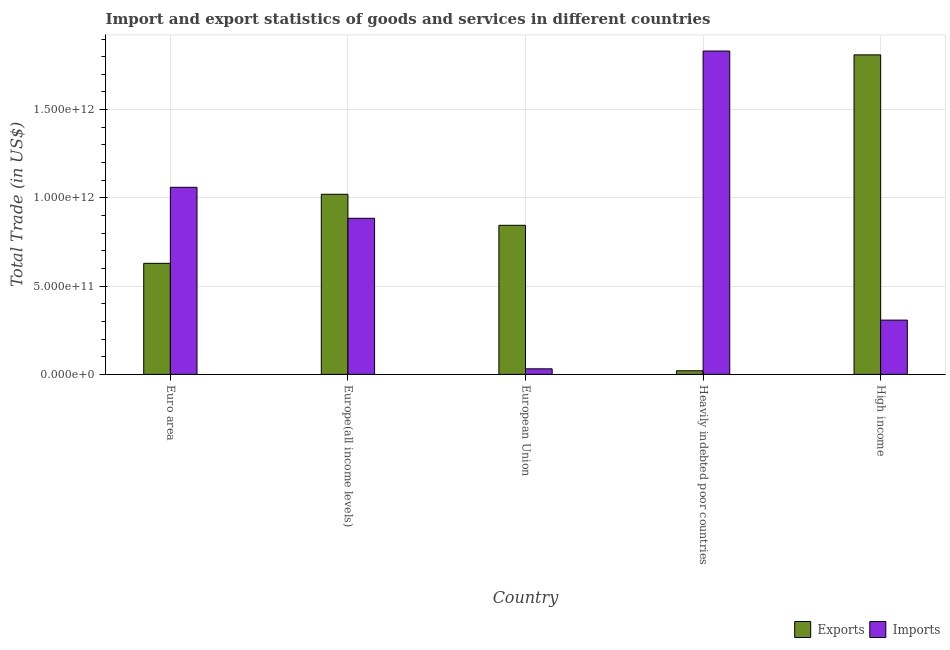How many different coloured bars are there?
Provide a short and direct response. 2. Are the number of bars per tick equal to the number of legend labels?
Offer a terse response. Yes. Are the number of bars on each tick of the X-axis equal?
Keep it short and to the point. Yes. How many bars are there on the 1st tick from the left?
Offer a very short reply. 2. How many bars are there on the 1st tick from the right?
Offer a very short reply. 2. What is the imports of goods and services in European Union?
Make the answer very short. 3.15e+1. Across all countries, what is the maximum imports of goods and services?
Provide a short and direct response. 1.83e+12. Across all countries, what is the minimum imports of goods and services?
Offer a terse response. 3.15e+1. In which country was the imports of goods and services maximum?
Offer a very short reply. Heavily indebted poor countries. In which country was the export of goods and services minimum?
Make the answer very short. Heavily indebted poor countries. What is the total export of goods and services in the graph?
Make the answer very short. 4.32e+12. What is the difference between the export of goods and services in Heavily indebted poor countries and that in High income?
Offer a very short reply. -1.79e+12. What is the difference between the imports of goods and services in European Union and the export of goods and services in Heavily indebted poor countries?
Give a very brief answer. 1.11e+1. What is the average imports of goods and services per country?
Make the answer very short. 8.23e+11. What is the difference between the imports of goods and services and export of goods and services in Europe(all income levels)?
Your answer should be compact. -1.36e+11. In how many countries, is the export of goods and services greater than 600000000000 US$?
Your answer should be compact. 4. What is the ratio of the imports of goods and services in Europe(all income levels) to that in Heavily indebted poor countries?
Your answer should be very brief. 0.48. Is the export of goods and services in European Union less than that in High income?
Give a very brief answer. Yes. What is the difference between the highest and the second highest imports of goods and services?
Provide a short and direct response. 7.72e+11. What is the difference between the highest and the lowest imports of goods and services?
Offer a very short reply. 1.80e+12. What does the 1st bar from the left in Heavily indebted poor countries represents?
Give a very brief answer. Exports. What does the 2nd bar from the right in Europe(all income levels) represents?
Your answer should be compact. Exports. How many bars are there?
Provide a short and direct response. 10. Are all the bars in the graph horizontal?
Your response must be concise. No. How many countries are there in the graph?
Provide a short and direct response. 5. What is the difference between two consecutive major ticks on the Y-axis?
Ensure brevity in your answer.  5.00e+11. Does the graph contain any zero values?
Keep it short and to the point. No. Does the graph contain grids?
Your answer should be compact. Yes. How many legend labels are there?
Keep it short and to the point. 2. What is the title of the graph?
Your answer should be very brief. Import and export statistics of goods and services in different countries. What is the label or title of the Y-axis?
Offer a terse response. Total Trade (in US$). What is the Total Trade (in US$) of Exports in Euro area?
Your answer should be very brief. 6.29e+11. What is the Total Trade (in US$) of Imports in Euro area?
Your response must be concise. 1.06e+12. What is the Total Trade (in US$) in Exports in Europe(all income levels)?
Provide a short and direct response. 1.02e+12. What is the Total Trade (in US$) of Imports in Europe(all income levels)?
Your answer should be compact. 8.84e+11. What is the Total Trade (in US$) of Exports in European Union?
Provide a succinct answer. 8.45e+11. What is the Total Trade (in US$) of Imports in European Union?
Provide a succinct answer. 3.15e+1. What is the Total Trade (in US$) in Exports in Heavily indebted poor countries?
Ensure brevity in your answer.  2.04e+1. What is the Total Trade (in US$) in Imports in Heavily indebted poor countries?
Keep it short and to the point. 1.83e+12. What is the Total Trade (in US$) in Exports in High income?
Keep it short and to the point. 1.81e+12. What is the Total Trade (in US$) of Imports in High income?
Your answer should be compact. 3.07e+11. Across all countries, what is the maximum Total Trade (in US$) in Exports?
Provide a succinct answer. 1.81e+12. Across all countries, what is the maximum Total Trade (in US$) in Imports?
Your answer should be compact. 1.83e+12. Across all countries, what is the minimum Total Trade (in US$) of Exports?
Provide a succinct answer. 2.04e+1. Across all countries, what is the minimum Total Trade (in US$) of Imports?
Your answer should be very brief. 3.15e+1. What is the total Total Trade (in US$) in Exports in the graph?
Your response must be concise. 4.32e+12. What is the total Total Trade (in US$) of Imports in the graph?
Offer a terse response. 4.12e+12. What is the difference between the Total Trade (in US$) in Exports in Euro area and that in Europe(all income levels)?
Offer a very short reply. -3.91e+11. What is the difference between the Total Trade (in US$) of Imports in Euro area and that in Europe(all income levels)?
Offer a terse response. 1.76e+11. What is the difference between the Total Trade (in US$) in Exports in Euro area and that in European Union?
Give a very brief answer. -2.15e+11. What is the difference between the Total Trade (in US$) in Imports in Euro area and that in European Union?
Provide a succinct answer. 1.03e+12. What is the difference between the Total Trade (in US$) in Exports in Euro area and that in Heavily indebted poor countries?
Give a very brief answer. 6.09e+11. What is the difference between the Total Trade (in US$) of Imports in Euro area and that in Heavily indebted poor countries?
Offer a terse response. -7.72e+11. What is the difference between the Total Trade (in US$) of Exports in Euro area and that in High income?
Keep it short and to the point. -1.18e+12. What is the difference between the Total Trade (in US$) of Imports in Euro area and that in High income?
Your answer should be very brief. 7.53e+11. What is the difference between the Total Trade (in US$) in Exports in Europe(all income levels) and that in European Union?
Make the answer very short. 1.76e+11. What is the difference between the Total Trade (in US$) of Imports in Europe(all income levels) and that in European Union?
Offer a very short reply. 8.53e+11. What is the difference between the Total Trade (in US$) of Exports in Europe(all income levels) and that in Heavily indebted poor countries?
Offer a very short reply. 1.00e+12. What is the difference between the Total Trade (in US$) in Imports in Europe(all income levels) and that in Heavily indebted poor countries?
Give a very brief answer. -9.48e+11. What is the difference between the Total Trade (in US$) in Exports in Europe(all income levels) and that in High income?
Keep it short and to the point. -7.90e+11. What is the difference between the Total Trade (in US$) in Imports in Europe(all income levels) and that in High income?
Give a very brief answer. 5.77e+11. What is the difference between the Total Trade (in US$) of Exports in European Union and that in Heavily indebted poor countries?
Your response must be concise. 8.24e+11. What is the difference between the Total Trade (in US$) in Imports in European Union and that in Heavily indebted poor countries?
Ensure brevity in your answer.  -1.80e+12. What is the difference between the Total Trade (in US$) in Exports in European Union and that in High income?
Ensure brevity in your answer.  -9.66e+11. What is the difference between the Total Trade (in US$) of Imports in European Union and that in High income?
Your answer should be compact. -2.76e+11. What is the difference between the Total Trade (in US$) in Exports in Heavily indebted poor countries and that in High income?
Offer a terse response. -1.79e+12. What is the difference between the Total Trade (in US$) in Imports in Heavily indebted poor countries and that in High income?
Your answer should be very brief. 1.52e+12. What is the difference between the Total Trade (in US$) of Exports in Euro area and the Total Trade (in US$) of Imports in Europe(all income levels)?
Ensure brevity in your answer.  -2.55e+11. What is the difference between the Total Trade (in US$) in Exports in Euro area and the Total Trade (in US$) in Imports in European Union?
Your answer should be compact. 5.98e+11. What is the difference between the Total Trade (in US$) of Exports in Euro area and the Total Trade (in US$) of Imports in Heavily indebted poor countries?
Offer a terse response. -1.20e+12. What is the difference between the Total Trade (in US$) of Exports in Euro area and the Total Trade (in US$) of Imports in High income?
Ensure brevity in your answer.  3.22e+11. What is the difference between the Total Trade (in US$) in Exports in Europe(all income levels) and the Total Trade (in US$) in Imports in European Union?
Your answer should be very brief. 9.89e+11. What is the difference between the Total Trade (in US$) of Exports in Europe(all income levels) and the Total Trade (in US$) of Imports in Heavily indebted poor countries?
Ensure brevity in your answer.  -8.12e+11. What is the difference between the Total Trade (in US$) of Exports in Europe(all income levels) and the Total Trade (in US$) of Imports in High income?
Offer a very short reply. 7.13e+11. What is the difference between the Total Trade (in US$) of Exports in European Union and the Total Trade (in US$) of Imports in Heavily indebted poor countries?
Your answer should be compact. -9.87e+11. What is the difference between the Total Trade (in US$) of Exports in European Union and the Total Trade (in US$) of Imports in High income?
Keep it short and to the point. 5.37e+11. What is the difference between the Total Trade (in US$) in Exports in Heavily indebted poor countries and the Total Trade (in US$) in Imports in High income?
Make the answer very short. -2.87e+11. What is the average Total Trade (in US$) of Exports per country?
Offer a terse response. 8.65e+11. What is the average Total Trade (in US$) in Imports per country?
Make the answer very short. 8.23e+11. What is the difference between the Total Trade (in US$) in Exports and Total Trade (in US$) in Imports in Euro area?
Offer a very short reply. -4.31e+11. What is the difference between the Total Trade (in US$) of Exports and Total Trade (in US$) of Imports in Europe(all income levels)?
Offer a very short reply. 1.36e+11. What is the difference between the Total Trade (in US$) of Exports and Total Trade (in US$) of Imports in European Union?
Your response must be concise. 8.13e+11. What is the difference between the Total Trade (in US$) in Exports and Total Trade (in US$) in Imports in Heavily indebted poor countries?
Provide a succinct answer. -1.81e+12. What is the difference between the Total Trade (in US$) of Exports and Total Trade (in US$) of Imports in High income?
Provide a succinct answer. 1.50e+12. What is the ratio of the Total Trade (in US$) of Exports in Euro area to that in Europe(all income levels)?
Provide a short and direct response. 0.62. What is the ratio of the Total Trade (in US$) in Imports in Euro area to that in Europe(all income levels)?
Ensure brevity in your answer.  1.2. What is the ratio of the Total Trade (in US$) in Exports in Euro area to that in European Union?
Provide a short and direct response. 0.74. What is the ratio of the Total Trade (in US$) of Imports in Euro area to that in European Union?
Your answer should be compact. 33.65. What is the ratio of the Total Trade (in US$) of Exports in Euro area to that in Heavily indebted poor countries?
Give a very brief answer. 30.86. What is the ratio of the Total Trade (in US$) in Imports in Euro area to that in Heavily indebted poor countries?
Offer a terse response. 0.58. What is the ratio of the Total Trade (in US$) in Exports in Euro area to that in High income?
Give a very brief answer. 0.35. What is the ratio of the Total Trade (in US$) of Imports in Euro area to that in High income?
Your answer should be compact. 3.45. What is the ratio of the Total Trade (in US$) in Exports in Europe(all income levels) to that in European Union?
Offer a very short reply. 1.21. What is the ratio of the Total Trade (in US$) of Imports in Europe(all income levels) to that in European Union?
Offer a very short reply. 28.08. What is the ratio of the Total Trade (in US$) in Exports in Europe(all income levels) to that in Heavily indebted poor countries?
Your answer should be very brief. 50.05. What is the ratio of the Total Trade (in US$) of Imports in Europe(all income levels) to that in Heavily indebted poor countries?
Your answer should be very brief. 0.48. What is the ratio of the Total Trade (in US$) in Exports in Europe(all income levels) to that in High income?
Your answer should be very brief. 0.56. What is the ratio of the Total Trade (in US$) of Imports in Europe(all income levels) to that in High income?
Ensure brevity in your answer.  2.88. What is the ratio of the Total Trade (in US$) of Exports in European Union to that in Heavily indebted poor countries?
Ensure brevity in your answer.  41.42. What is the ratio of the Total Trade (in US$) in Imports in European Union to that in Heavily indebted poor countries?
Ensure brevity in your answer.  0.02. What is the ratio of the Total Trade (in US$) of Exports in European Union to that in High income?
Provide a succinct answer. 0.47. What is the ratio of the Total Trade (in US$) in Imports in European Union to that in High income?
Provide a short and direct response. 0.1. What is the ratio of the Total Trade (in US$) in Exports in Heavily indebted poor countries to that in High income?
Your answer should be very brief. 0.01. What is the ratio of the Total Trade (in US$) of Imports in Heavily indebted poor countries to that in High income?
Give a very brief answer. 5.96. What is the difference between the highest and the second highest Total Trade (in US$) in Exports?
Your response must be concise. 7.90e+11. What is the difference between the highest and the second highest Total Trade (in US$) of Imports?
Provide a succinct answer. 7.72e+11. What is the difference between the highest and the lowest Total Trade (in US$) of Exports?
Provide a short and direct response. 1.79e+12. What is the difference between the highest and the lowest Total Trade (in US$) of Imports?
Offer a very short reply. 1.80e+12. 